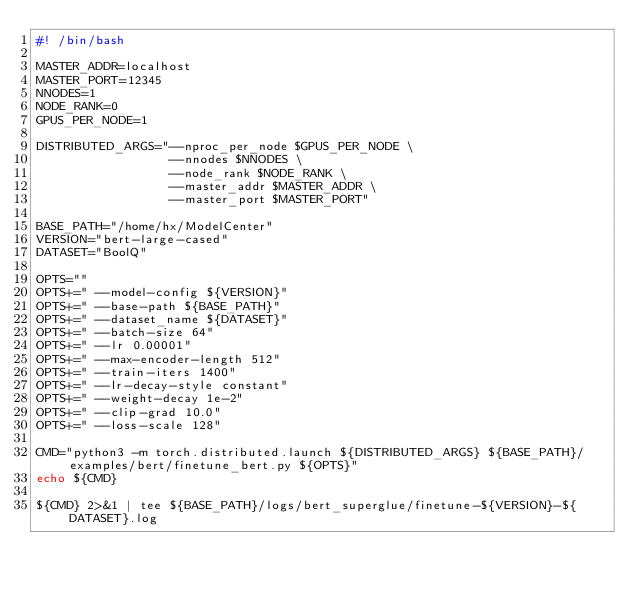Convert code to text. <code><loc_0><loc_0><loc_500><loc_500><_Bash_>#! /bin/bash

MASTER_ADDR=localhost
MASTER_PORT=12345
NNODES=1
NODE_RANK=0
GPUS_PER_NODE=1

DISTRIBUTED_ARGS="--nproc_per_node $GPUS_PER_NODE \
                  --nnodes $NNODES \
                  --node_rank $NODE_RANK \
                  --master_addr $MASTER_ADDR \
                  --master_port $MASTER_PORT"

BASE_PATH="/home/hx/ModelCenter"
VERSION="bert-large-cased"
DATASET="BoolQ"

OPTS=""
OPTS+=" --model-config ${VERSION}"
OPTS+=" --base-path ${BASE_PATH}"
OPTS+=" --dataset_name ${DATASET}"
OPTS+=" --batch-size 64"
OPTS+=" --lr 0.00001"
OPTS+=" --max-encoder-length 512"
OPTS+=" --train-iters 1400"
OPTS+=" --lr-decay-style constant"
OPTS+=" --weight-decay 1e-2"
OPTS+=" --clip-grad 10.0"
OPTS+=" --loss-scale 128"

CMD="python3 -m torch.distributed.launch ${DISTRIBUTED_ARGS} ${BASE_PATH}/examples/bert/finetune_bert.py ${OPTS}"
echo ${CMD}

${CMD} 2>&1 | tee ${BASE_PATH}/logs/bert_superglue/finetune-${VERSION}-${DATASET}.log</code> 